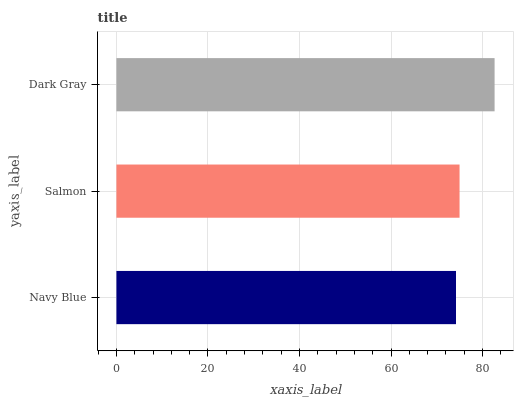Is Navy Blue the minimum?
Answer yes or no. Yes. Is Dark Gray the maximum?
Answer yes or no. Yes. Is Salmon the minimum?
Answer yes or no. No. Is Salmon the maximum?
Answer yes or no. No. Is Salmon greater than Navy Blue?
Answer yes or no. Yes. Is Navy Blue less than Salmon?
Answer yes or no. Yes. Is Navy Blue greater than Salmon?
Answer yes or no. No. Is Salmon less than Navy Blue?
Answer yes or no. No. Is Salmon the high median?
Answer yes or no. Yes. Is Salmon the low median?
Answer yes or no. Yes. Is Navy Blue the high median?
Answer yes or no. No. Is Navy Blue the low median?
Answer yes or no. No. 